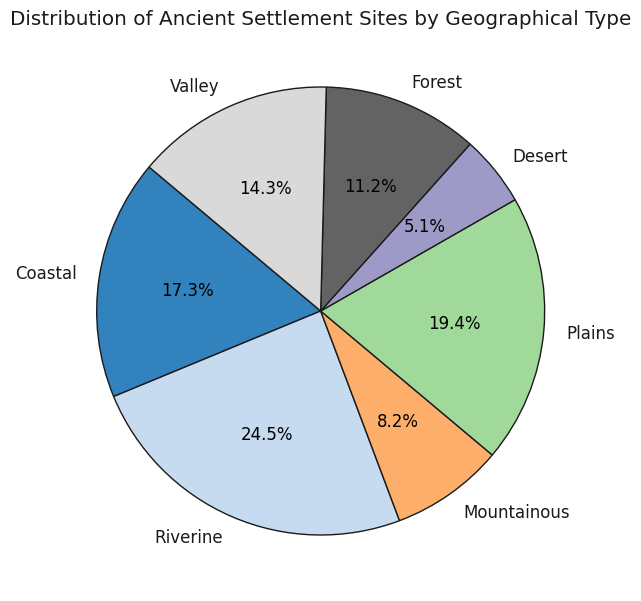What's the most common geographical type for ancient settlement sites? To determine the most common geographical type, we look at the section of the pie chart that has the largest slice. The largest slice indicates the geographical type with the highest number of settlement sites.
Answer: Riverine Which geographical type has the smallest number of settlement sites? To find the geographical type with the smallest number of settlement sites, we identify the smallest slice of the pie chart.
Answer: Desert How many more settlement sites are there in the Plains compared to the Coastal region? First, find the number of settlement sites in each geographical type from the chart: Plains have 95 and Coastal have 85. Subtract the number of sites in Coastal from Plains (95 - 85).
Answer: 10 What percentage of the settlement sites are in riverine areas? In a pie chart, the percentage is shown directly on the plot. Locate the percentage label for the Riverine section of the chart.
Answer: 24.5% Which two geographical types together make up exactly half of the settlement sites? To answer this, find geographical types whose percentages sum to 50%. Riverine has 24.5%, and Plains have 19.4%. Adding these gives 43.9%, which is less. Adding Coastal’s 17.3% to Riverine’s 24.5% yields 41.8%. Finally, adding Plains’ 19.4% to Forest’s 11.2% yields 30.6%. Combining the Riverine’s 24.5% and Valley’s 14.3% yields 38.8%. Thus, no exact combination sums to 50%. Instead, find an approximate by evaluating sums of pairs.
Answer: No exact pair sums to 50% Which geographical type is more common, Forest or Mountainous? Compare the sizes of the slices labeled Forest and Mountainous; the larger slice corresponds to the more common geographical type. Forest has a larger slice than Mountainous.
Answer: Forest 